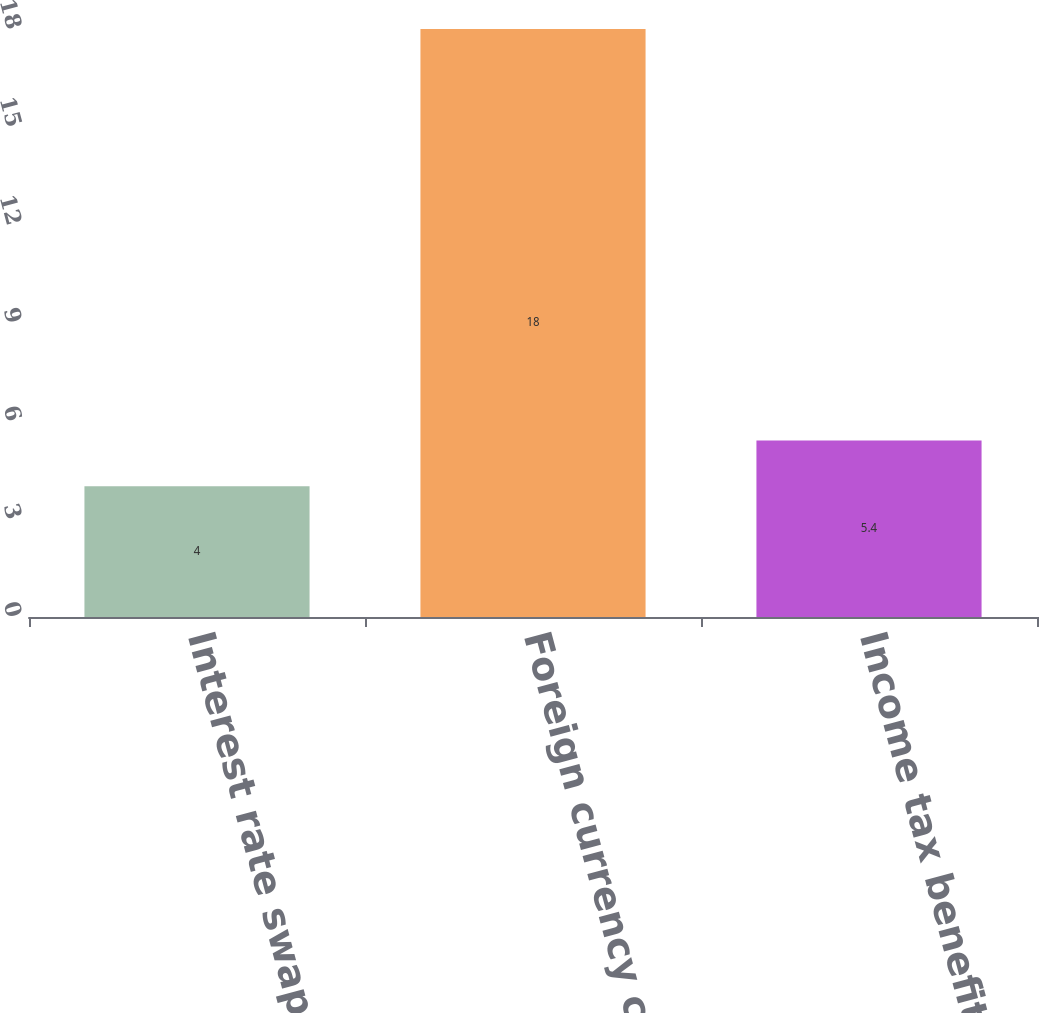<chart> <loc_0><loc_0><loc_500><loc_500><bar_chart><fcel>Interest rate swaps<fcel>Foreign currency contracts<fcel>Income tax benefit/(expense)<nl><fcel>4<fcel>18<fcel>5.4<nl></chart> 